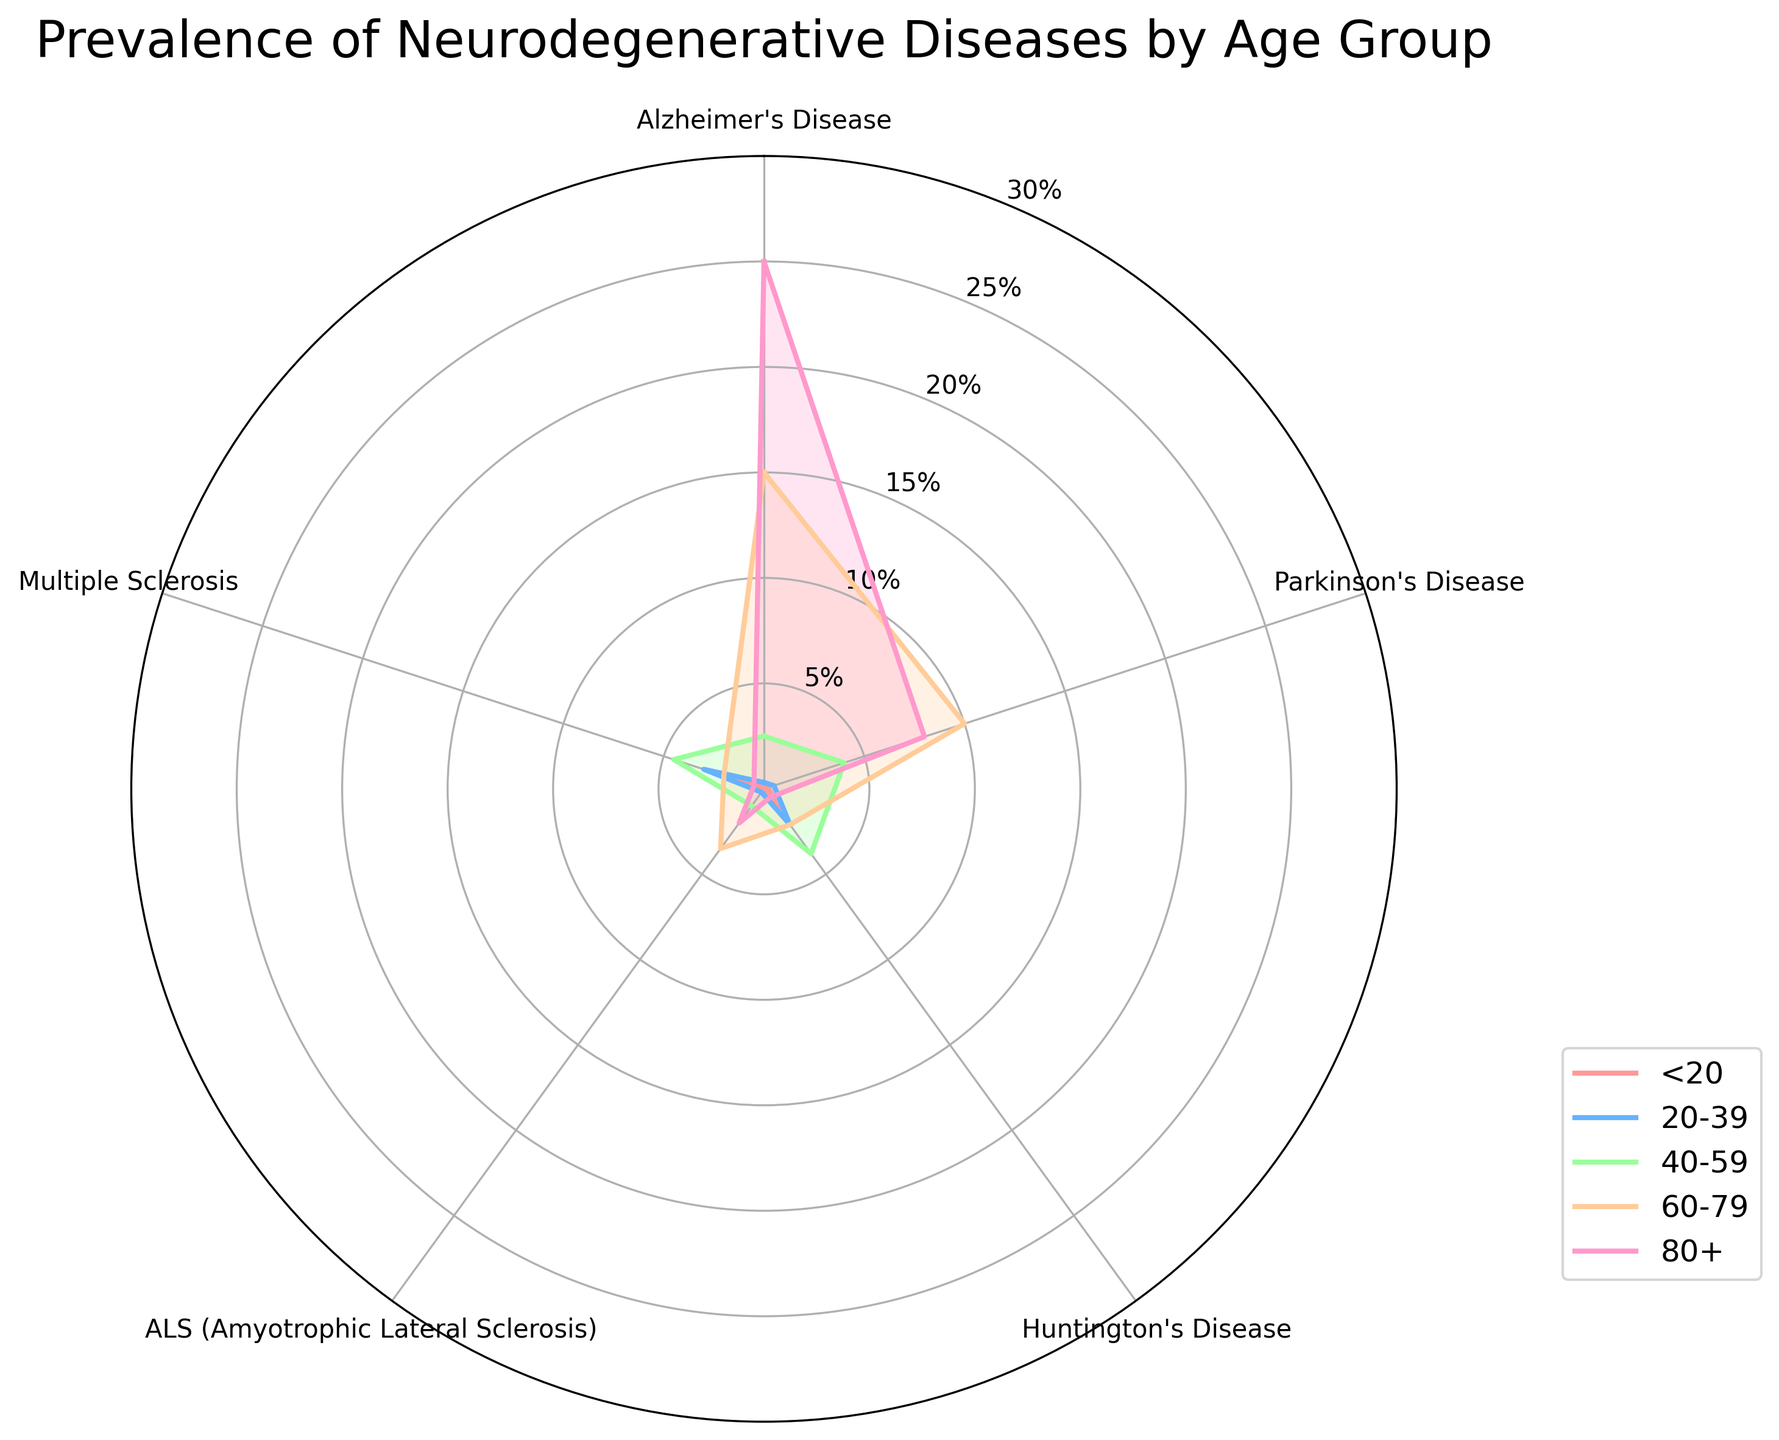What is the title of the chart? The title is the main heading presented at the top of the chart. It helps in understanding the context of the data visualized. The title of the chart is found at the top center.
Answer: Prevalence of Neurodegenerative Diseases by Age Group How many age groups are represented in the chart? Count the distinct sectors or legends representing different age ranges. Each line corresponds to an age group.
Answer: 5 Which age group has the highest prevalence of Alzheimer's Disease? Find the line representing each age group and check their values along the Alzheimer's Disease axis at around 12 o'clock position. The 80+ age group line reaches the highest value on this dimension.
Answer: 80+ What is the minimum prevalence rate of Huntington's Disease for the age group 20-39? Identify the 20-39 age group, then find the point on the chart corresponding to Huntington's Disease axis (around 3 o'clock). The value is 2.1%.
Answer: 2.1% Which disease has the highest prevalence for the under 20 age group? Trace the line corresponding to the '<20' age group and find the maximum value along the disease axes. Multiple Sclerosis shows the highest value at approximately 1.5%.
Answer: Multiple Sclerosis Which age group has the largest spread (difference between maximum and minimum values) of disease prevalence? Calculate the difference between the maximum and minimum values for each age group’s radar chart values. The 40-59 group shows a spread from 0.1 to 4.5.
Answer: 40-59 What is the difference in Parkinson’s Disease prevalence between the 60-79 and 80+ age groups? Locate the lines for the 60-79 and 80+ age groups along the Parkinson’s Disease axis (around 2 o'clock) and calculate the difference (10.0 - 8.0 = 2.0).
Answer: 2.0 Which disease has the lowest prevalence across all age groups except the <20 age group? Check each axis for its values (ignoring the <20 group), and note that Huntington's Disease consistently shows low values except for the <20 group where it is at 1.2%.
Answer: Huntington's Disease 